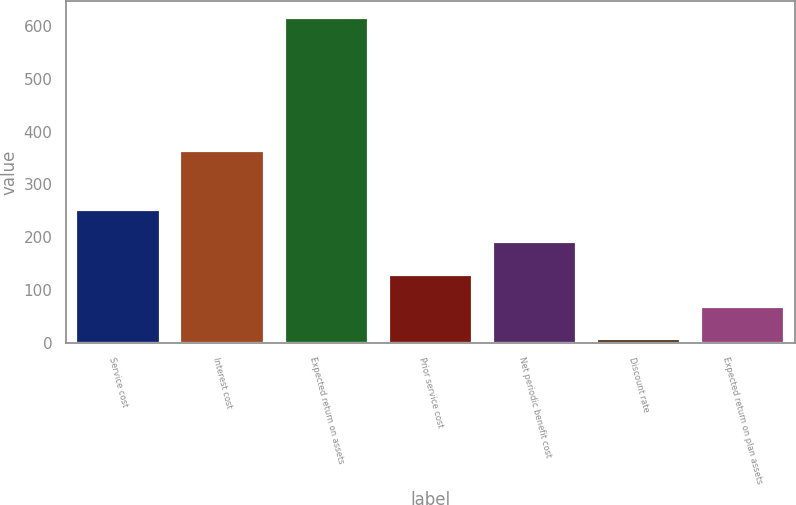Convert chart. <chart><loc_0><loc_0><loc_500><loc_500><bar_chart><fcel>Service cost<fcel>Interest cost<fcel>Expected return on assets<fcel>Prior service cost<fcel>Net periodic benefit cost<fcel>Discount rate<fcel>Expected return on plan assets<nl><fcel>251.06<fcel>363<fcel>616<fcel>129.41<fcel>190.24<fcel>7.75<fcel>68.58<nl></chart> 